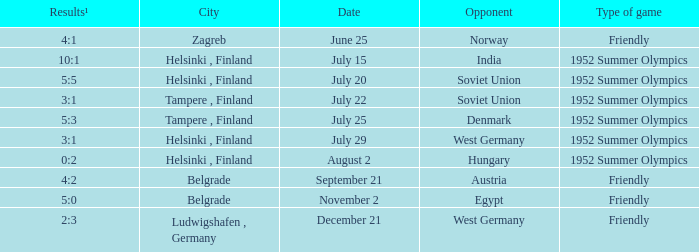What Type of game has a Results¹ of 10:1? 1952 Summer Olympics. 